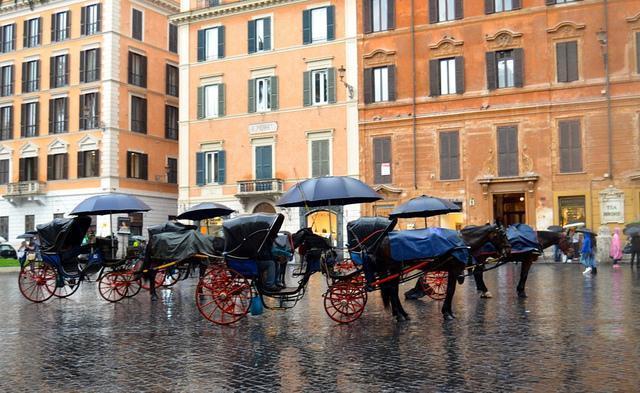How many umbrellas are open?
Give a very brief answer. 4. How many umbrellas are there?
Give a very brief answer. 2. How many horses are there?
Give a very brief answer. 3. How many remotes are on the table?
Give a very brief answer. 0. 